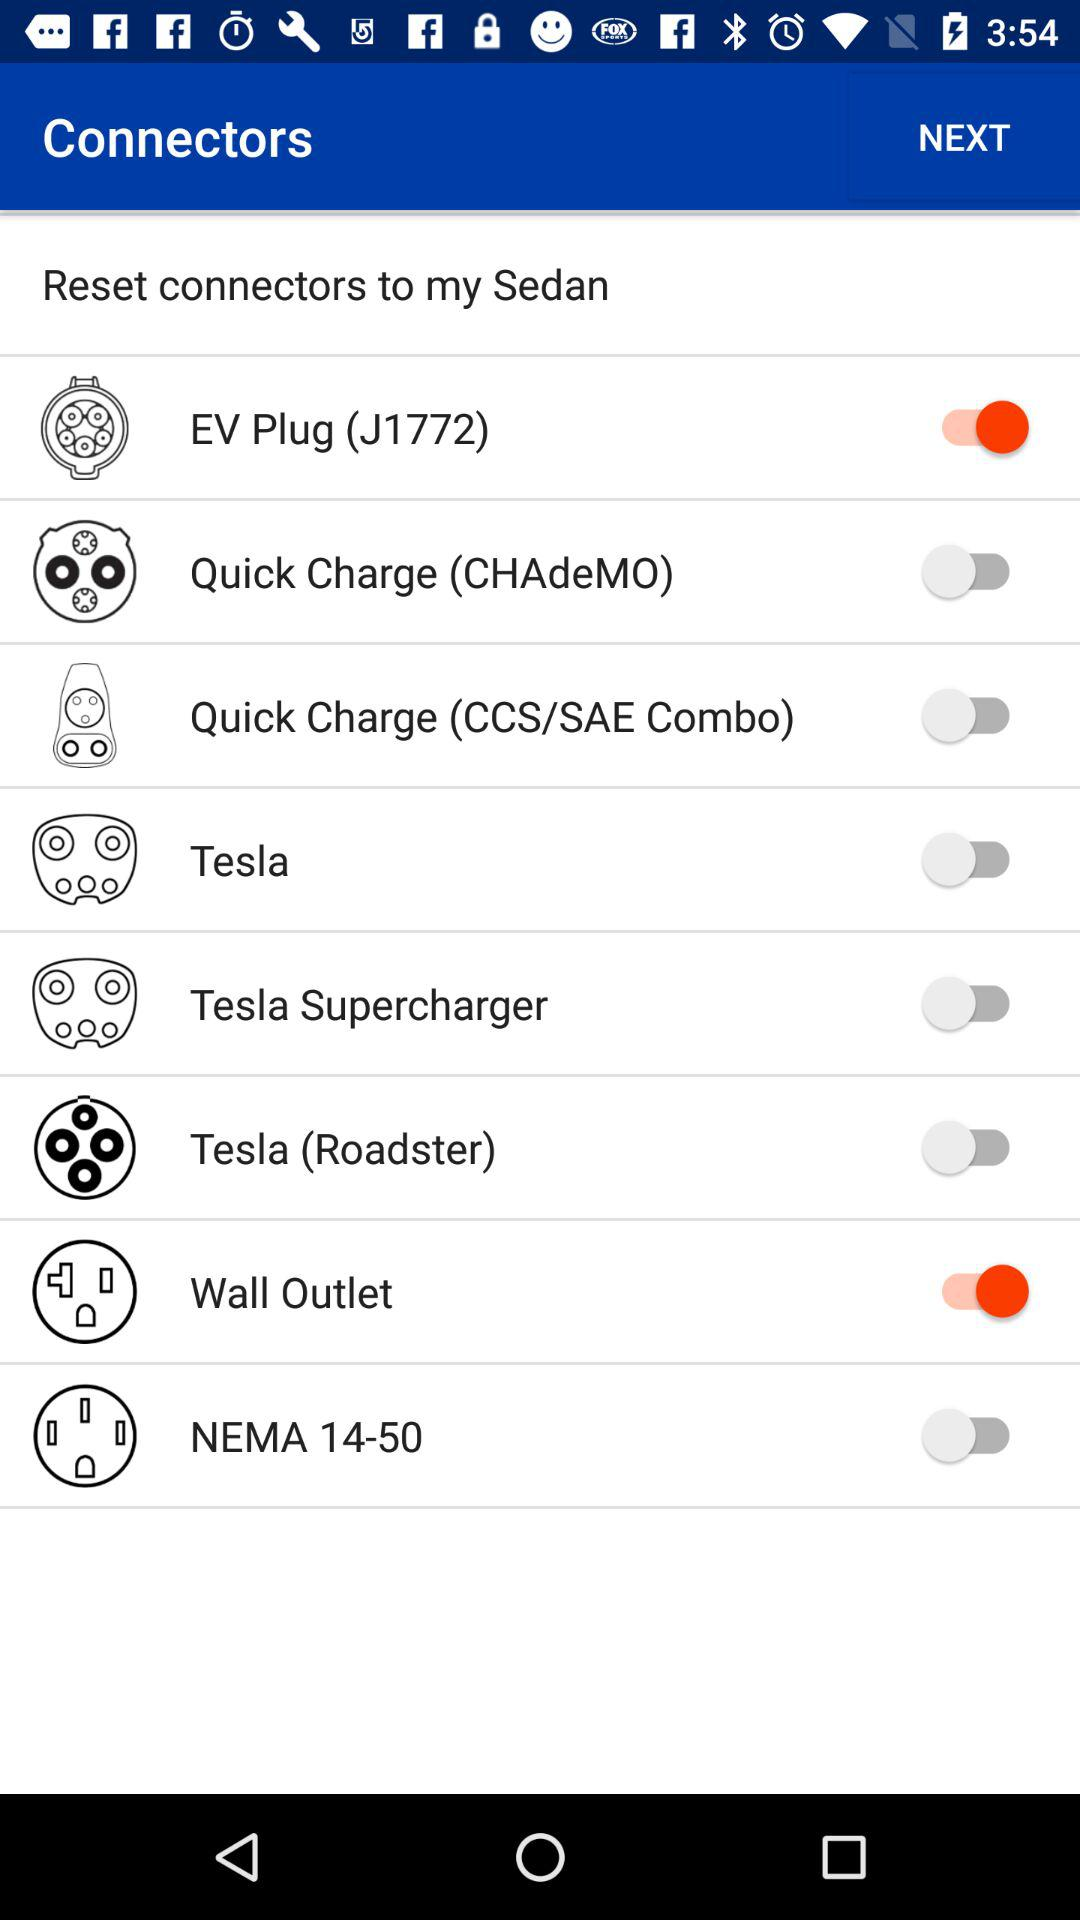What's the status of "Wall Outlet"? The status of "Wall Outlet" is "on". 